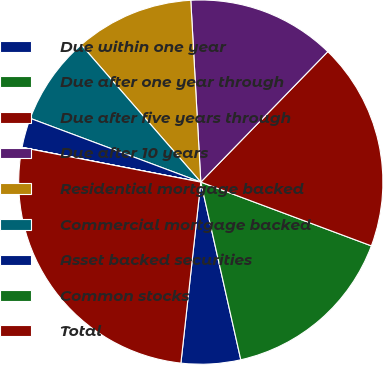<chart> <loc_0><loc_0><loc_500><loc_500><pie_chart><fcel>Due within one year<fcel>Due after one year through<fcel>Due after five years through<fcel>Due after 10 years<fcel>Residential mortgage backed<fcel>Commercial mortgage backed<fcel>Asset backed securities<fcel>Common stocks<fcel>Total<nl><fcel>5.27%<fcel>15.78%<fcel>18.41%<fcel>13.16%<fcel>10.53%<fcel>7.9%<fcel>2.64%<fcel>0.01%<fcel>26.3%<nl></chart> 